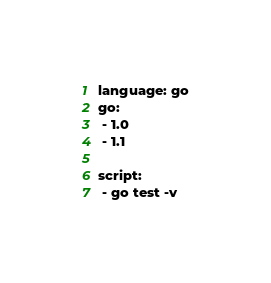Convert code to text. <code><loc_0><loc_0><loc_500><loc_500><_YAML_>language: go
go:
 - 1.0
 - 1.1 

script:
 - go test -v
</code> 